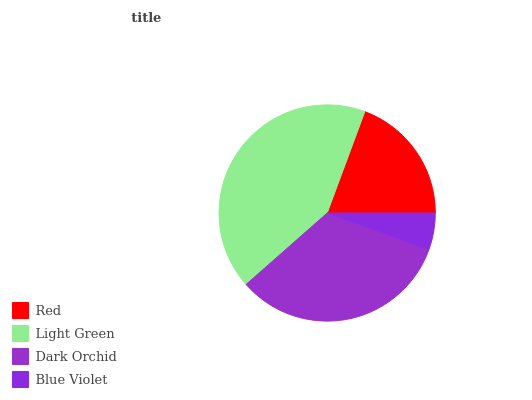Is Blue Violet the minimum?
Answer yes or no. Yes. Is Light Green the maximum?
Answer yes or no. Yes. Is Dark Orchid the minimum?
Answer yes or no. No. Is Dark Orchid the maximum?
Answer yes or no. No. Is Light Green greater than Dark Orchid?
Answer yes or no. Yes. Is Dark Orchid less than Light Green?
Answer yes or no. Yes. Is Dark Orchid greater than Light Green?
Answer yes or no. No. Is Light Green less than Dark Orchid?
Answer yes or no. No. Is Dark Orchid the high median?
Answer yes or no. Yes. Is Red the low median?
Answer yes or no. Yes. Is Blue Violet the high median?
Answer yes or no. No. Is Dark Orchid the low median?
Answer yes or no. No. 